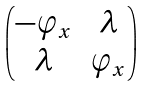<formula> <loc_0><loc_0><loc_500><loc_500>\begin{pmatrix} - \varphi _ { x } & \lambda \\ \lambda & \varphi _ { x } \end{pmatrix}</formula> 